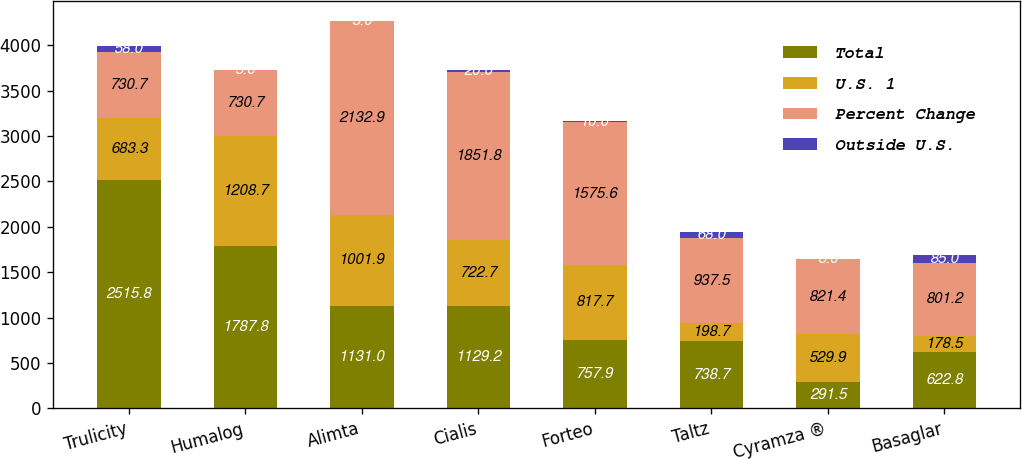<chart> <loc_0><loc_0><loc_500><loc_500><stacked_bar_chart><ecel><fcel>Trulicity<fcel>Humalog<fcel>Alimta<fcel>Cialis<fcel>Forteo<fcel>Taltz<fcel>Cyramza ®<fcel>Basaglar<nl><fcel>Total<fcel>2515.8<fcel>1787.8<fcel>1131<fcel>1129.2<fcel>757.9<fcel>738.7<fcel>291.5<fcel>622.8<nl><fcel>U.S. 1<fcel>683.3<fcel>1208.7<fcel>1001.9<fcel>722.7<fcel>817.7<fcel>198.7<fcel>529.9<fcel>178.5<nl><fcel>Percent Change<fcel>730.7<fcel>730.7<fcel>2132.9<fcel>1851.8<fcel>1575.6<fcel>937.5<fcel>821.4<fcel>801.2<nl><fcel>Outside U.S.<fcel>58<fcel>5<fcel>3<fcel>20<fcel>10<fcel>68<fcel>8<fcel>85<nl></chart> 